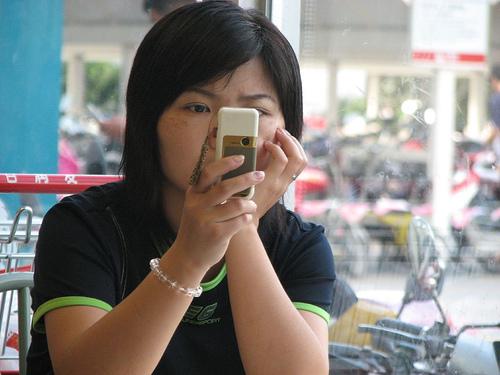What is the girl looking at?
Be succinct. Cell phone. Is she wearing glasses?
Be succinct. No. Is the in a public place?
Concise answer only. Yes. Which wrist has a bracelet?
Short answer required. Right. 